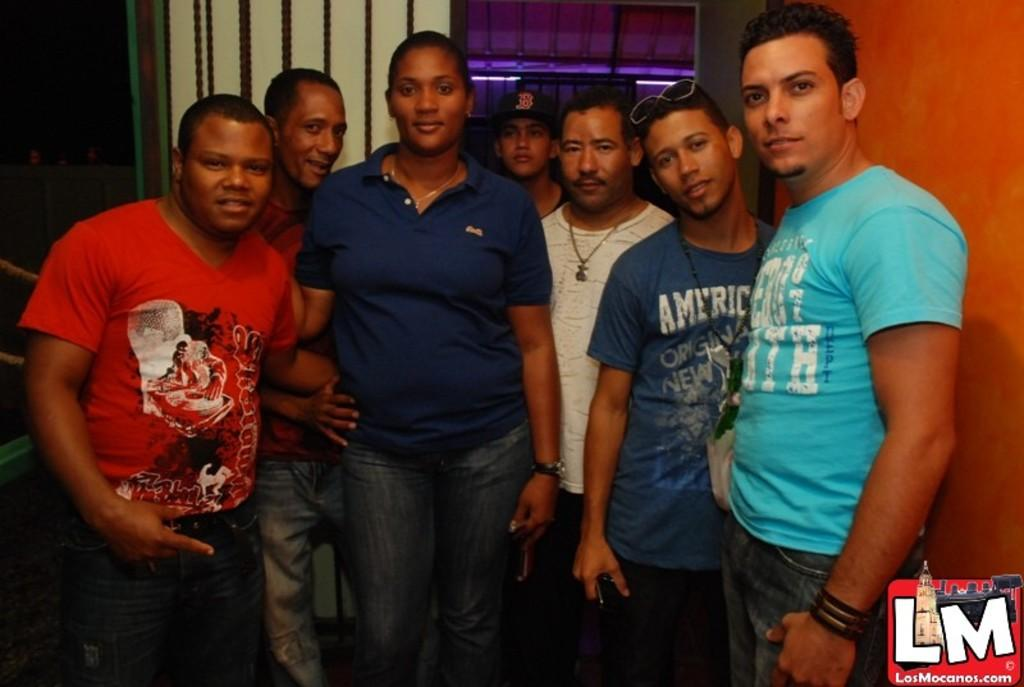How many people are in the image? There is a group of persons standing in the image, but the exact number cannot be determined from the provided facts. What is behind the persons in the image? There is a wall visible behind the persons in the image. Is there any text or symbol in the image? Yes, there is a logo and text in the bottom right corner of the image. What type of bead is being used to destroy the wall in the image? There is no bead or destruction present in the image. Can you tell me what animals are visible in the zoo in the image? There is no zoo or animals visible in the image. 